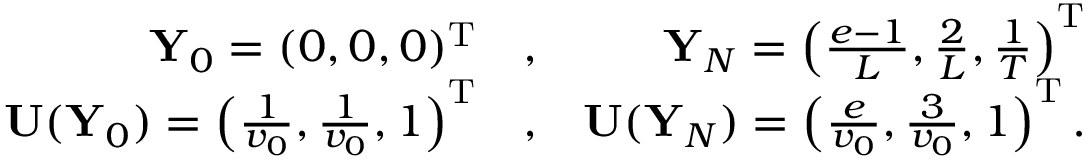Convert formula to latex. <formula><loc_0><loc_0><loc_500><loc_500>\begin{array} { r l r } { { \mathbf Y } _ { 0 } = ( 0 , 0 , 0 ) ^ { \mathrm T } } & { , } & { { \mathbf Y } _ { N } = \left ( \frac { e - 1 } { L } , \frac { 2 } { L } , \frac { 1 } { T } \right ) ^ { \mathrm T } } \\ { { \mathbf U } ( { \mathbf Y } _ { 0 } ) = \left ( \frac { 1 } { v _ { 0 } } , \frac { 1 } { v _ { 0 } } , 1 \right ) ^ { \mathrm T } } & { , } & { { \mathbf U } ( { \mathbf Y } _ { N } ) = \left ( \frac { e } { v _ { 0 } } , \frac { 3 } { v _ { 0 } } , 1 \right ) ^ { \mathrm T } . } \end{array}</formula> 